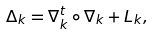Convert formula to latex. <formula><loc_0><loc_0><loc_500><loc_500>\Delta _ { k } = \nabla ^ { t } _ { k } \circ \nabla _ { k } + L _ { k } ,</formula> 